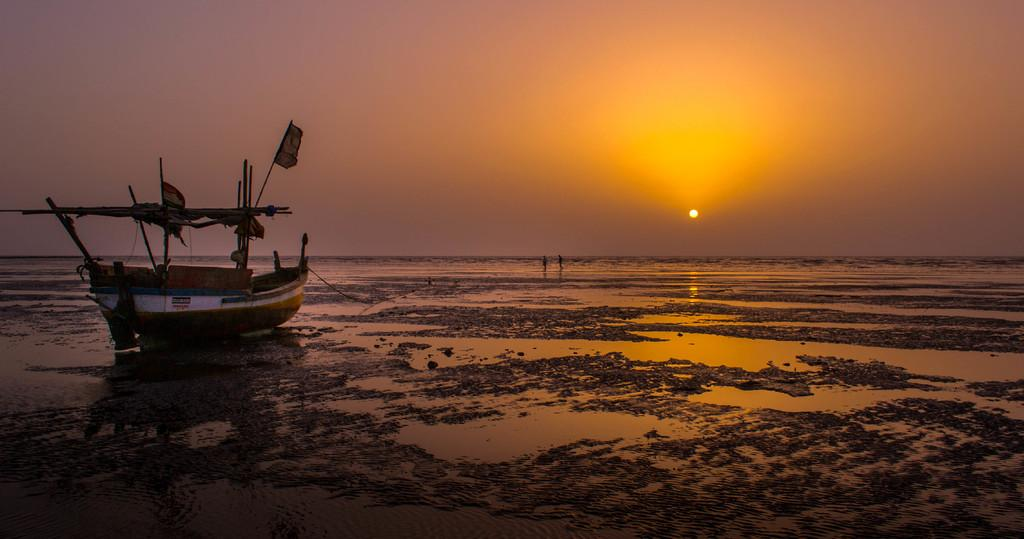What is at the bottom of the image? There is mud with water at the bottom of the image. What type of vehicle is in the image? There is a boat with poles in the image. What can be seen in the background of the image? There is water visible in the background of the image. What is visible at the top of the image? The sky is visible at the top of the image. What celestial body is present in the sky? The sun is present in the sky. How many eyes can be seen on the boat in the image? There are no eyes present on the boat in the image. What type of vase is visible in the water in the image? There is no vase present in the image; it features mud, water, and a boat with poles. Who is sitting on the throne in the image? There is no throne present in the image. 